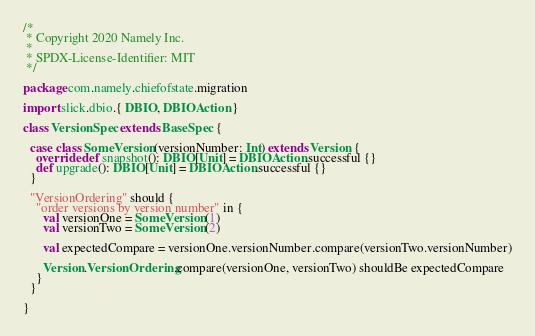<code> <loc_0><loc_0><loc_500><loc_500><_Scala_>/*
 * Copyright 2020 Namely Inc.
 *
 * SPDX-License-Identifier: MIT
 */

package com.namely.chiefofstate.migration

import slick.dbio.{ DBIO, DBIOAction }

class VersionSpec extends BaseSpec {

  case class SomeVersion(versionNumber: Int) extends Version {
    override def snapshot(): DBIO[Unit] = DBIOAction.successful {}
    def upgrade(): DBIO[Unit] = DBIOAction.successful {}
  }

  "VersionOrdering" should {
    "order versions by version number" in {
      val versionOne = SomeVersion(1)
      val versionTwo = SomeVersion(2)

      val expectedCompare = versionOne.versionNumber.compare(versionTwo.versionNumber)

      Version.VersionOrdering.compare(versionOne, versionTwo) shouldBe expectedCompare
    }
  }

}
</code> 